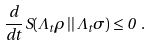<formula> <loc_0><loc_0><loc_500><loc_500>\frac { d } { d t } \, S ( \Lambda _ { t } \rho \, | | \, \Lambda _ { t } \sigma ) \leq 0 \ .</formula> 